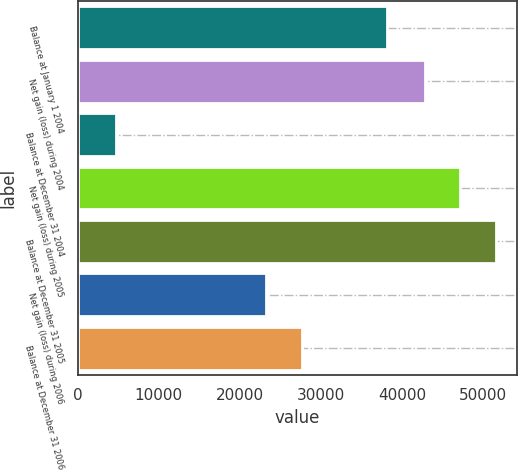Convert chart. <chart><loc_0><loc_0><loc_500><loc_500><bar_chart><fcel>Balance at January 1 2004<fcel>Net gain (loss) during 2004<fcel>Balance at December 31 2004<fcel>Net gain (loss) during 2005<fcel>Balance at December 31 2005<fcel>Net gain (loss) during 2006<fcel>Balance at December 31 2006<nl><fcel>38111<fcel>42823<fcel>4712<fcel>47209.4<fcel>51595.8<fcel>23265<fcel>27651.4<nl></chart> 